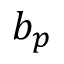Convert formula to latex. <formula><loc_0><loc_0><loc_500><loc_500>b _ { p }</formula> 